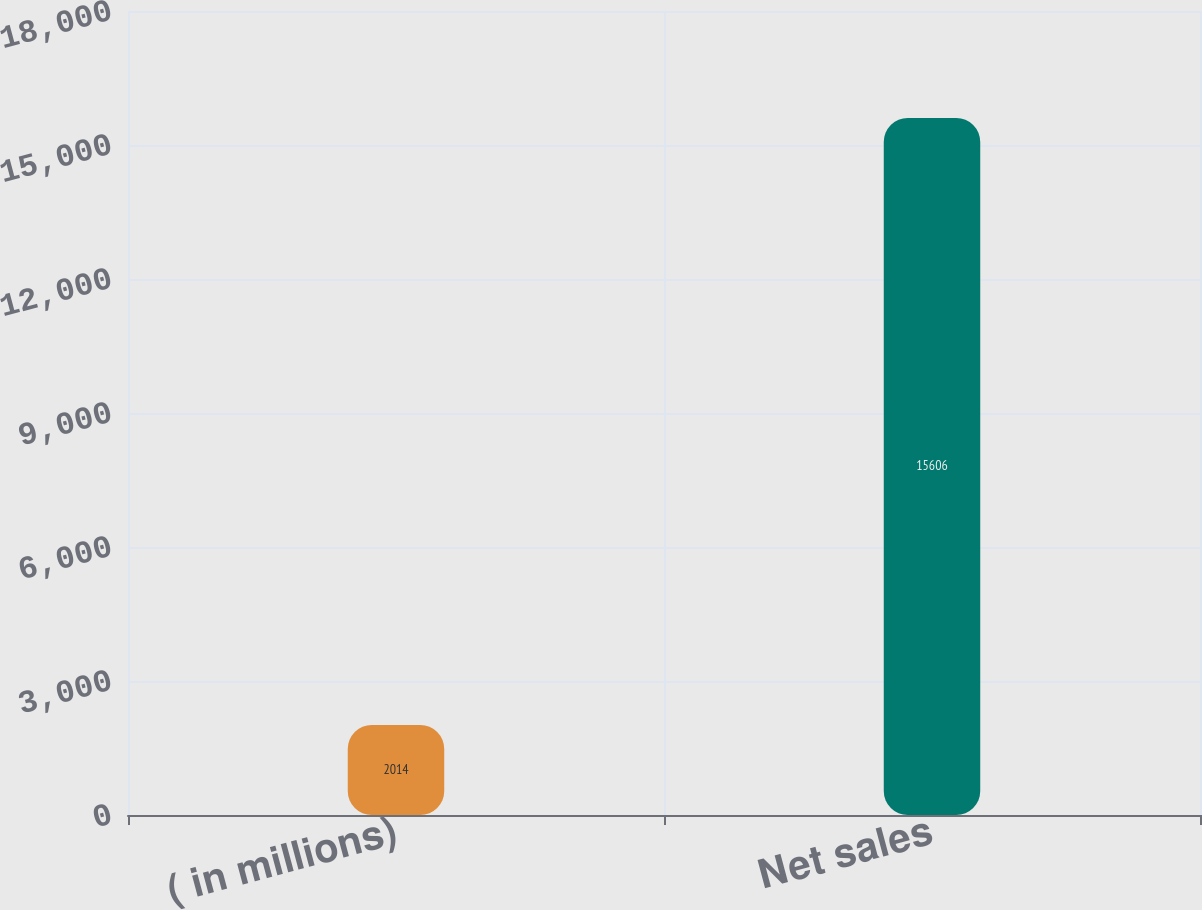<chart> <loc_0><loc_0><loc_500><loc_500><bar_chart><fcel>( in millions)<fcel>Net sales<nl><fcel>2014<fcel>15606<nl></chart> 